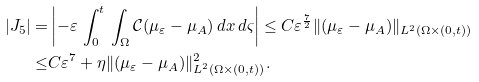Convert formula to latex. <formula><loc_0><loc_0><loc_500><loc_500>| J _ { 5 } | = & \left | - \varepsilon \, \int _ { 0 } ^ { t } \, \int _ { \Omega } \mathcal { C } ( \mu _ { \varepsilon } - \mu _ { A } ) \, d x \, d \varsigma \right | \leq C \varepsilon ^ { \frac { 7 } { 2 } } \| ( \mu _ { \varepsilon } - \mu _ { A } ) \| _ { L ^ { 2 } ( \Omega \times ( 0 , t ) ) } \\ \leq & C \varepsilon ^ { 7 } + \eta \| ( \mu _ { \varepsilon } - \mu _ { A } ) \| _ { L ^ { 2 } ( \Omega \times ( 0 , t ) ) } ^ { 2 } .</formula> 